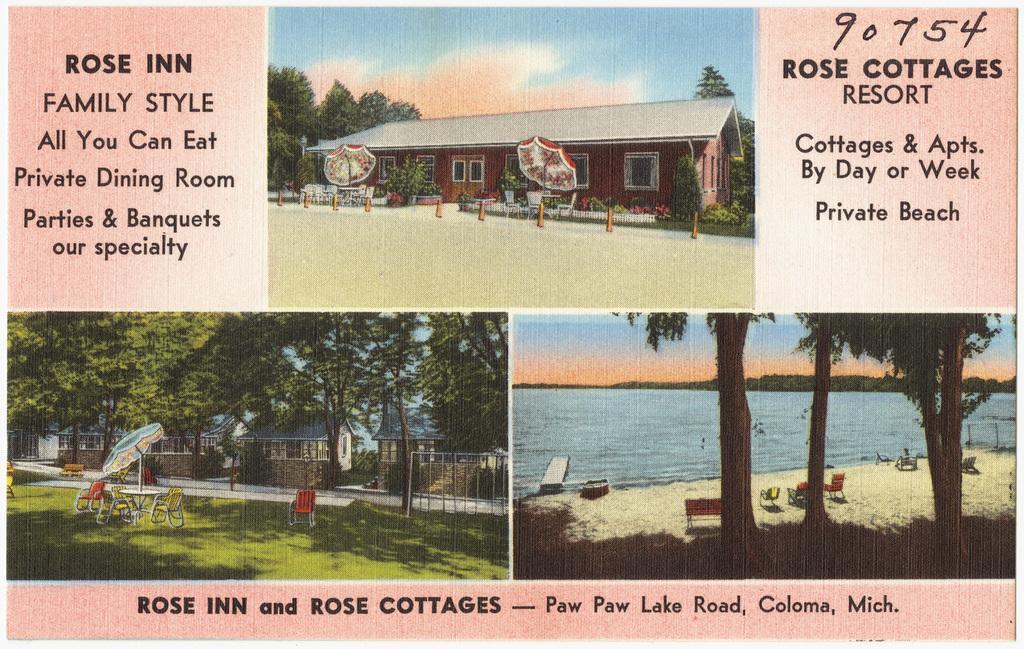Describe this image in one or two sentences. In this image there is a poster of a cottage resort with images of the resort and some text on it. 